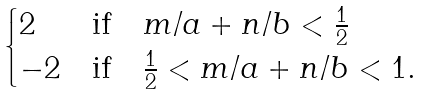Convert formula to latex. <formula><loc_0><loc_0><loc_500><loc_500>\begin{cases} 2 & \text {if} \quad m / a + n / b < \frac { 1 } { 2 } \\ - 2 & \text {if} \quad \frac { 1 } { 2 } < m / a + n / b < 1 . \end{cases}</formula> 